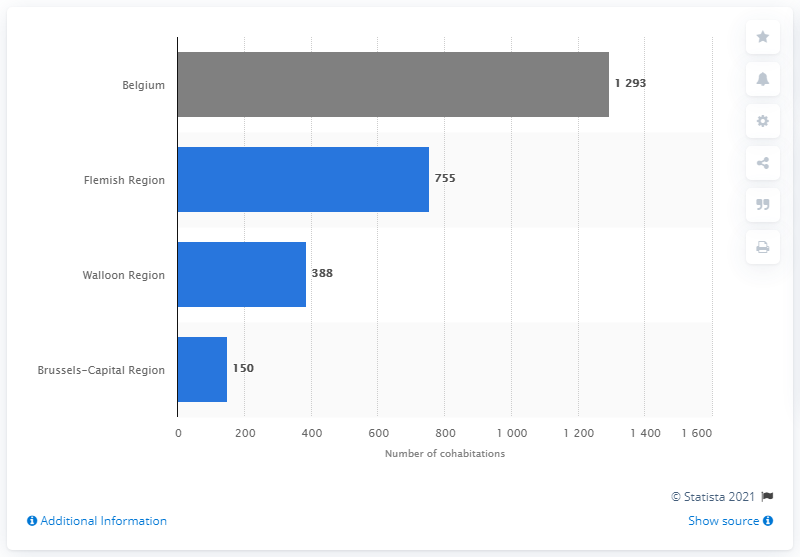Mention a couple of crucial points in this snapshot. In 2018, 755 cohabitation declarations were made in Flanders. 